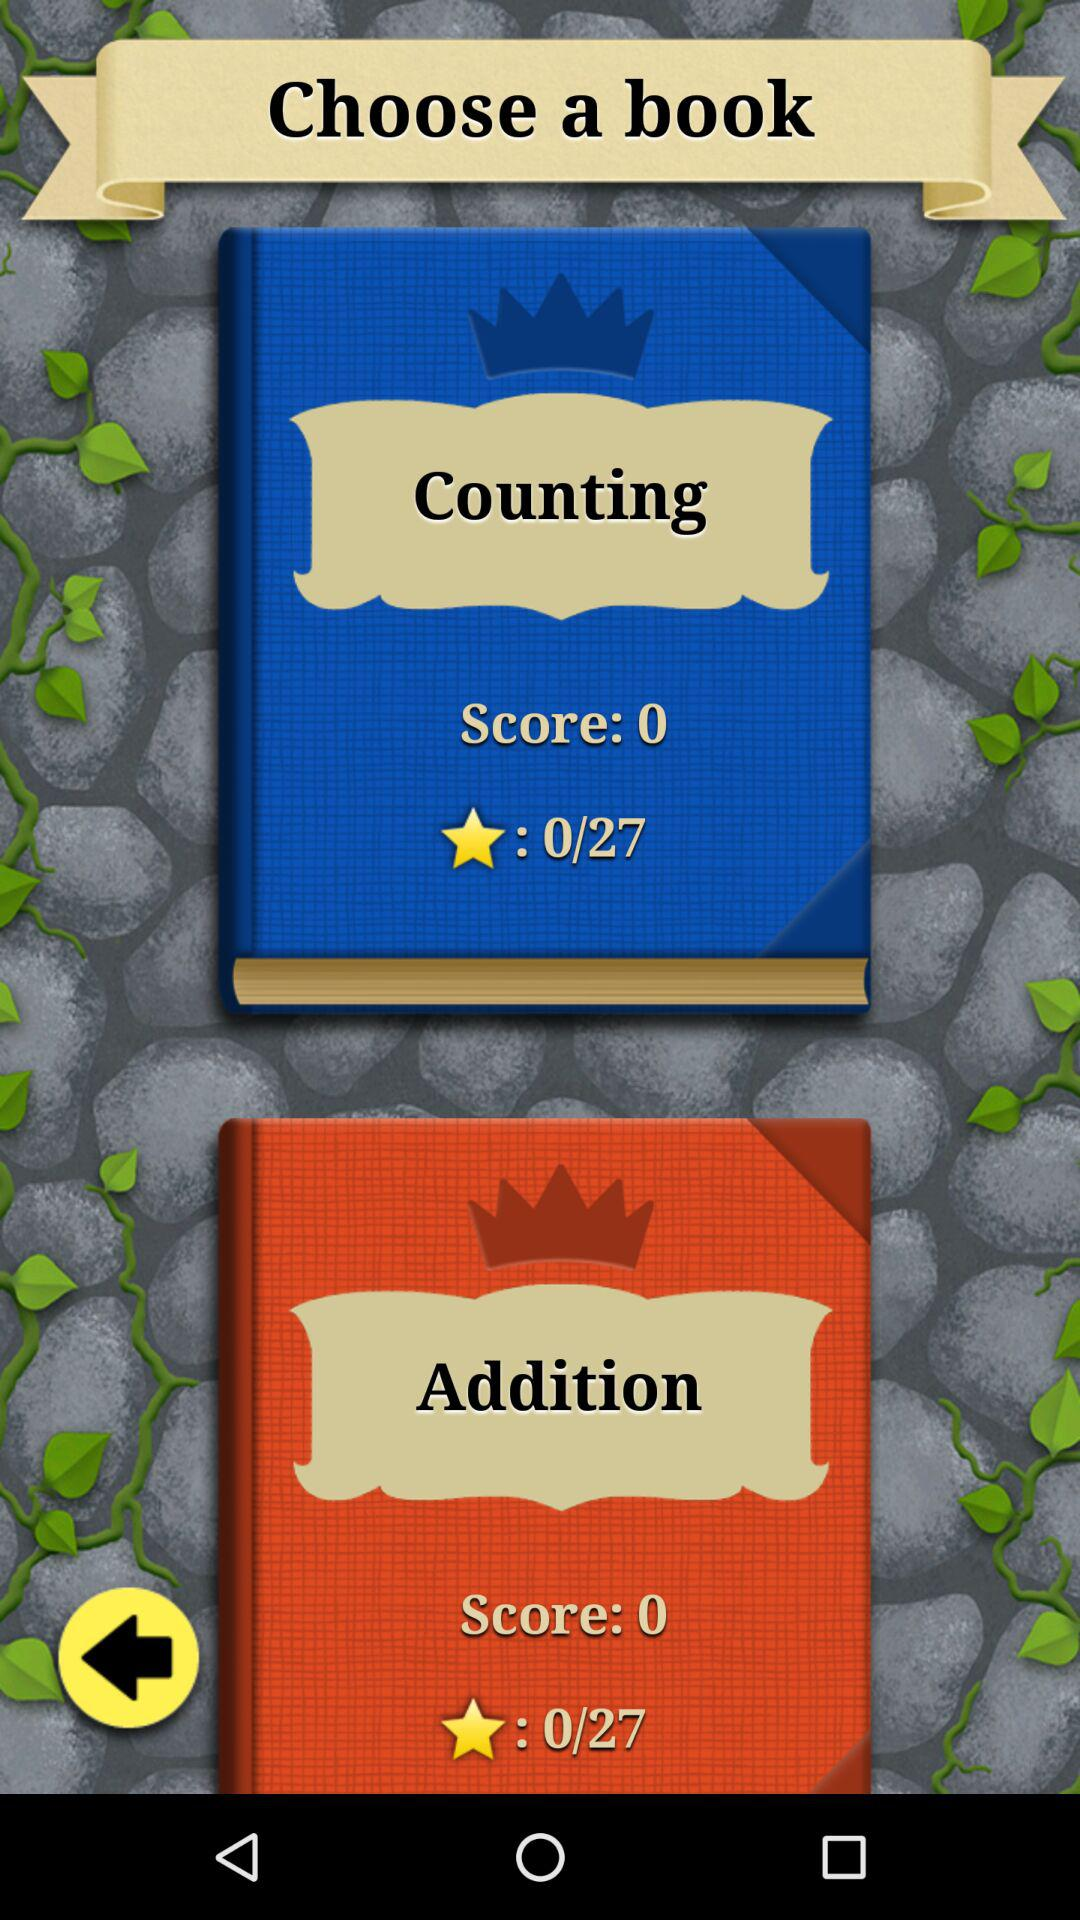What is the "Addition" score? The "Addition" score is 0. 